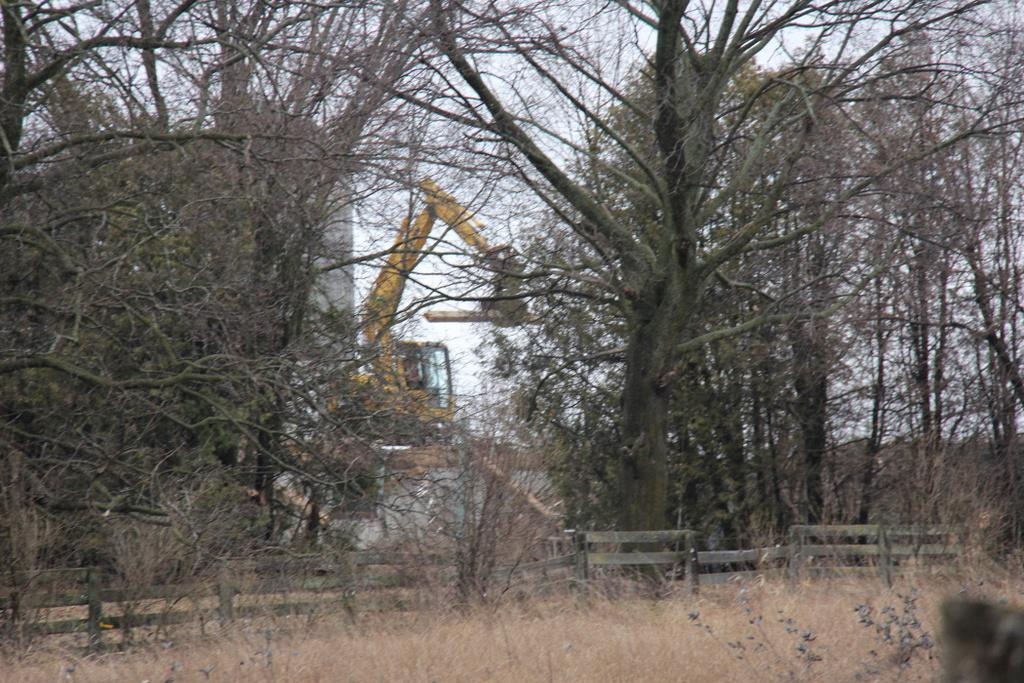What type of vegetation is present in the image? There is grass in the image. What type of structure can be seen in the image? There is a fence in the image. What other natural elements are present in the image? There are trees in the image. What can be seen in the background of the image? There is an excavator, a building, and the sky visible in the background of the image. What type of string is being used to tie the plants together in the image? There is no string or plants being tied together in the image; it features grass, trees, a fence, an excavator, a building, and the sky. How deep is the hole that the excavator is digging in the image? There is no hole being dug by the excavator in the image; it is simply visible in the background. 